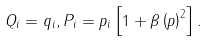<formula> <loc_0><loc_0><loc_500><loc_500>Q _ { i } = q _ { i } , P _ { i } = p _ { i } \left [ 1 + { \beta } \left ( p \right ) ^ { 2 } \right ] .</formula> 